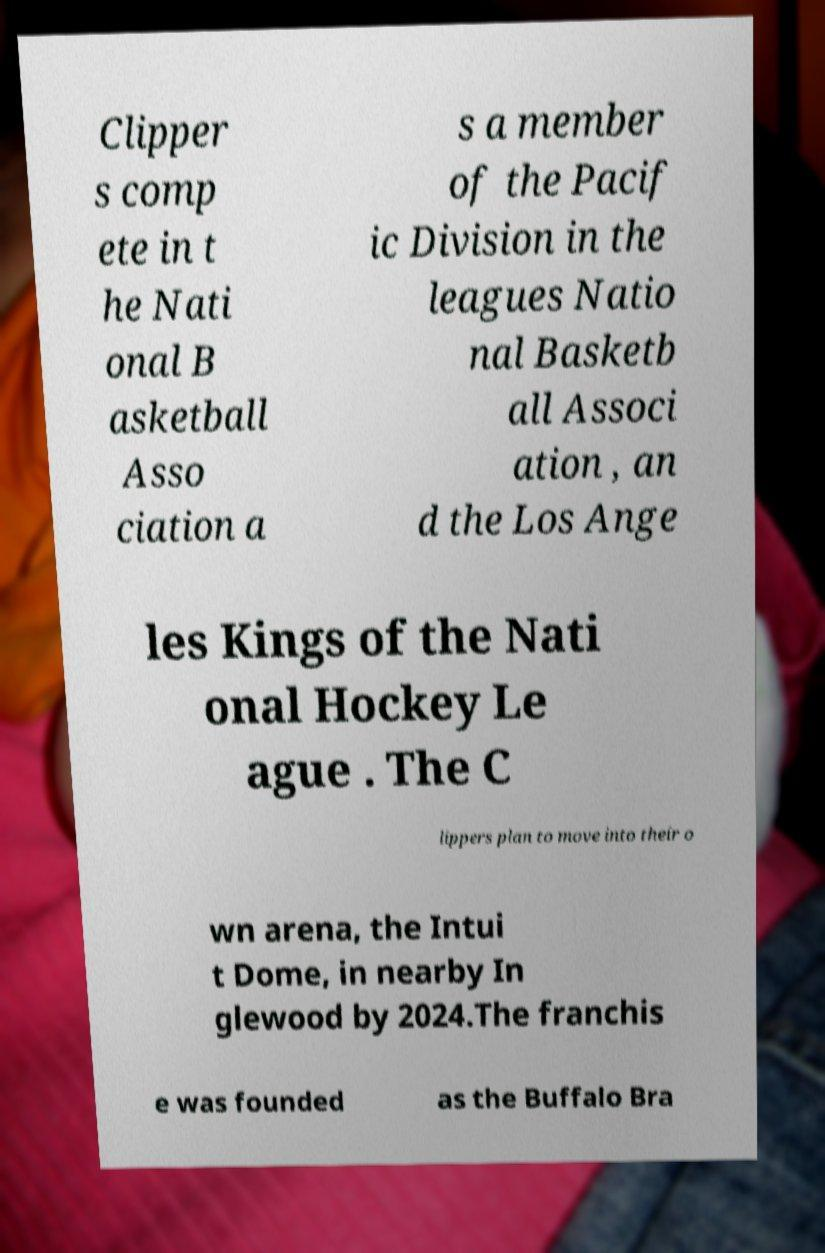Please identify and transcribe the text found in this image. Clipper s comp ete in t he Nati onal B asketball Asso ciation a s a member of the Pacif ic Division in the leagues Natio nal Basketb all Associ ation , an d the Los Ange les Kings of the Nati onal Hockey Le ague . The C lippers plan to move into their o wn arena, the Intui t Dome, in nearby In glewood by 2024.The franchis e was founded as the Buffalo Bra 